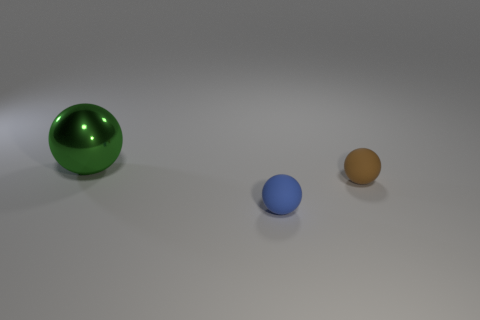Add 2 tiny blue objects. How many objects exist? 5 Subtract all large balls. Subtract all small yellow metallic cubes. How many objects are left? 2 Add 3 green balls. How many green balls are left? 4 Add 1 matte things. How many matte things exist? 3 Subtract 0 purple balls. How many objects are left? 3 